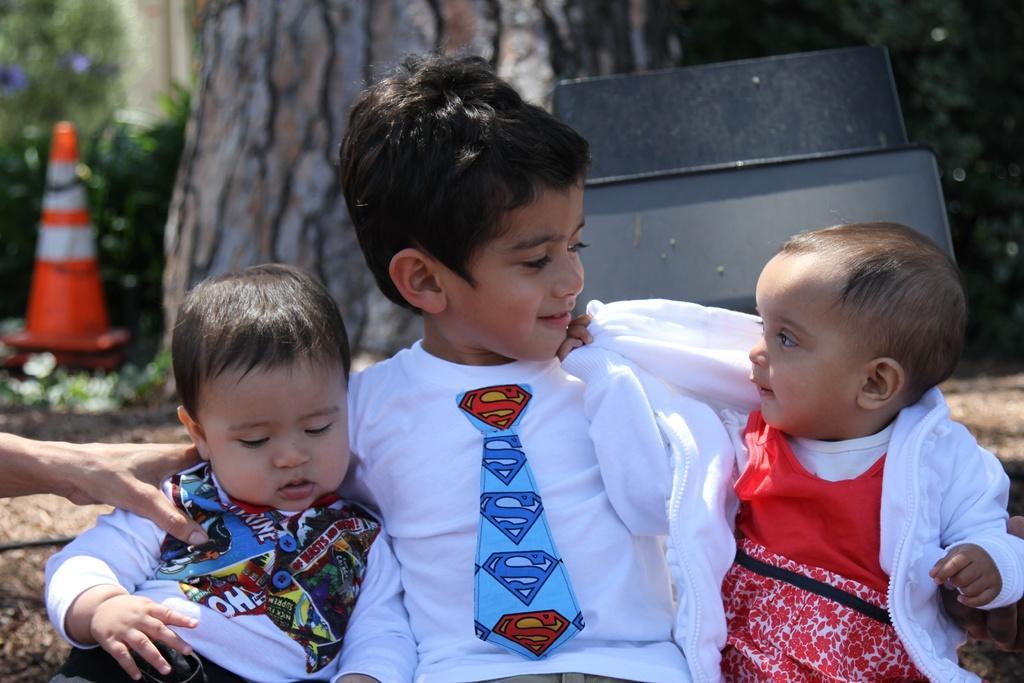Could you give a brief overview of what you see in this image? In this image we can see one boy sitting middle of the image, two babies sitting on the left and right side of the boy. One baby holding one object on the right side of the image, one person's hand holding a baby on the left side of the image, one object on the right side of the image, one object on the ground on the left side of the image, one safety pole on the ground, two black objects in the background, two small blue round objects near the trees in the background, some trees, some plants on the ground and the background is blurred. 